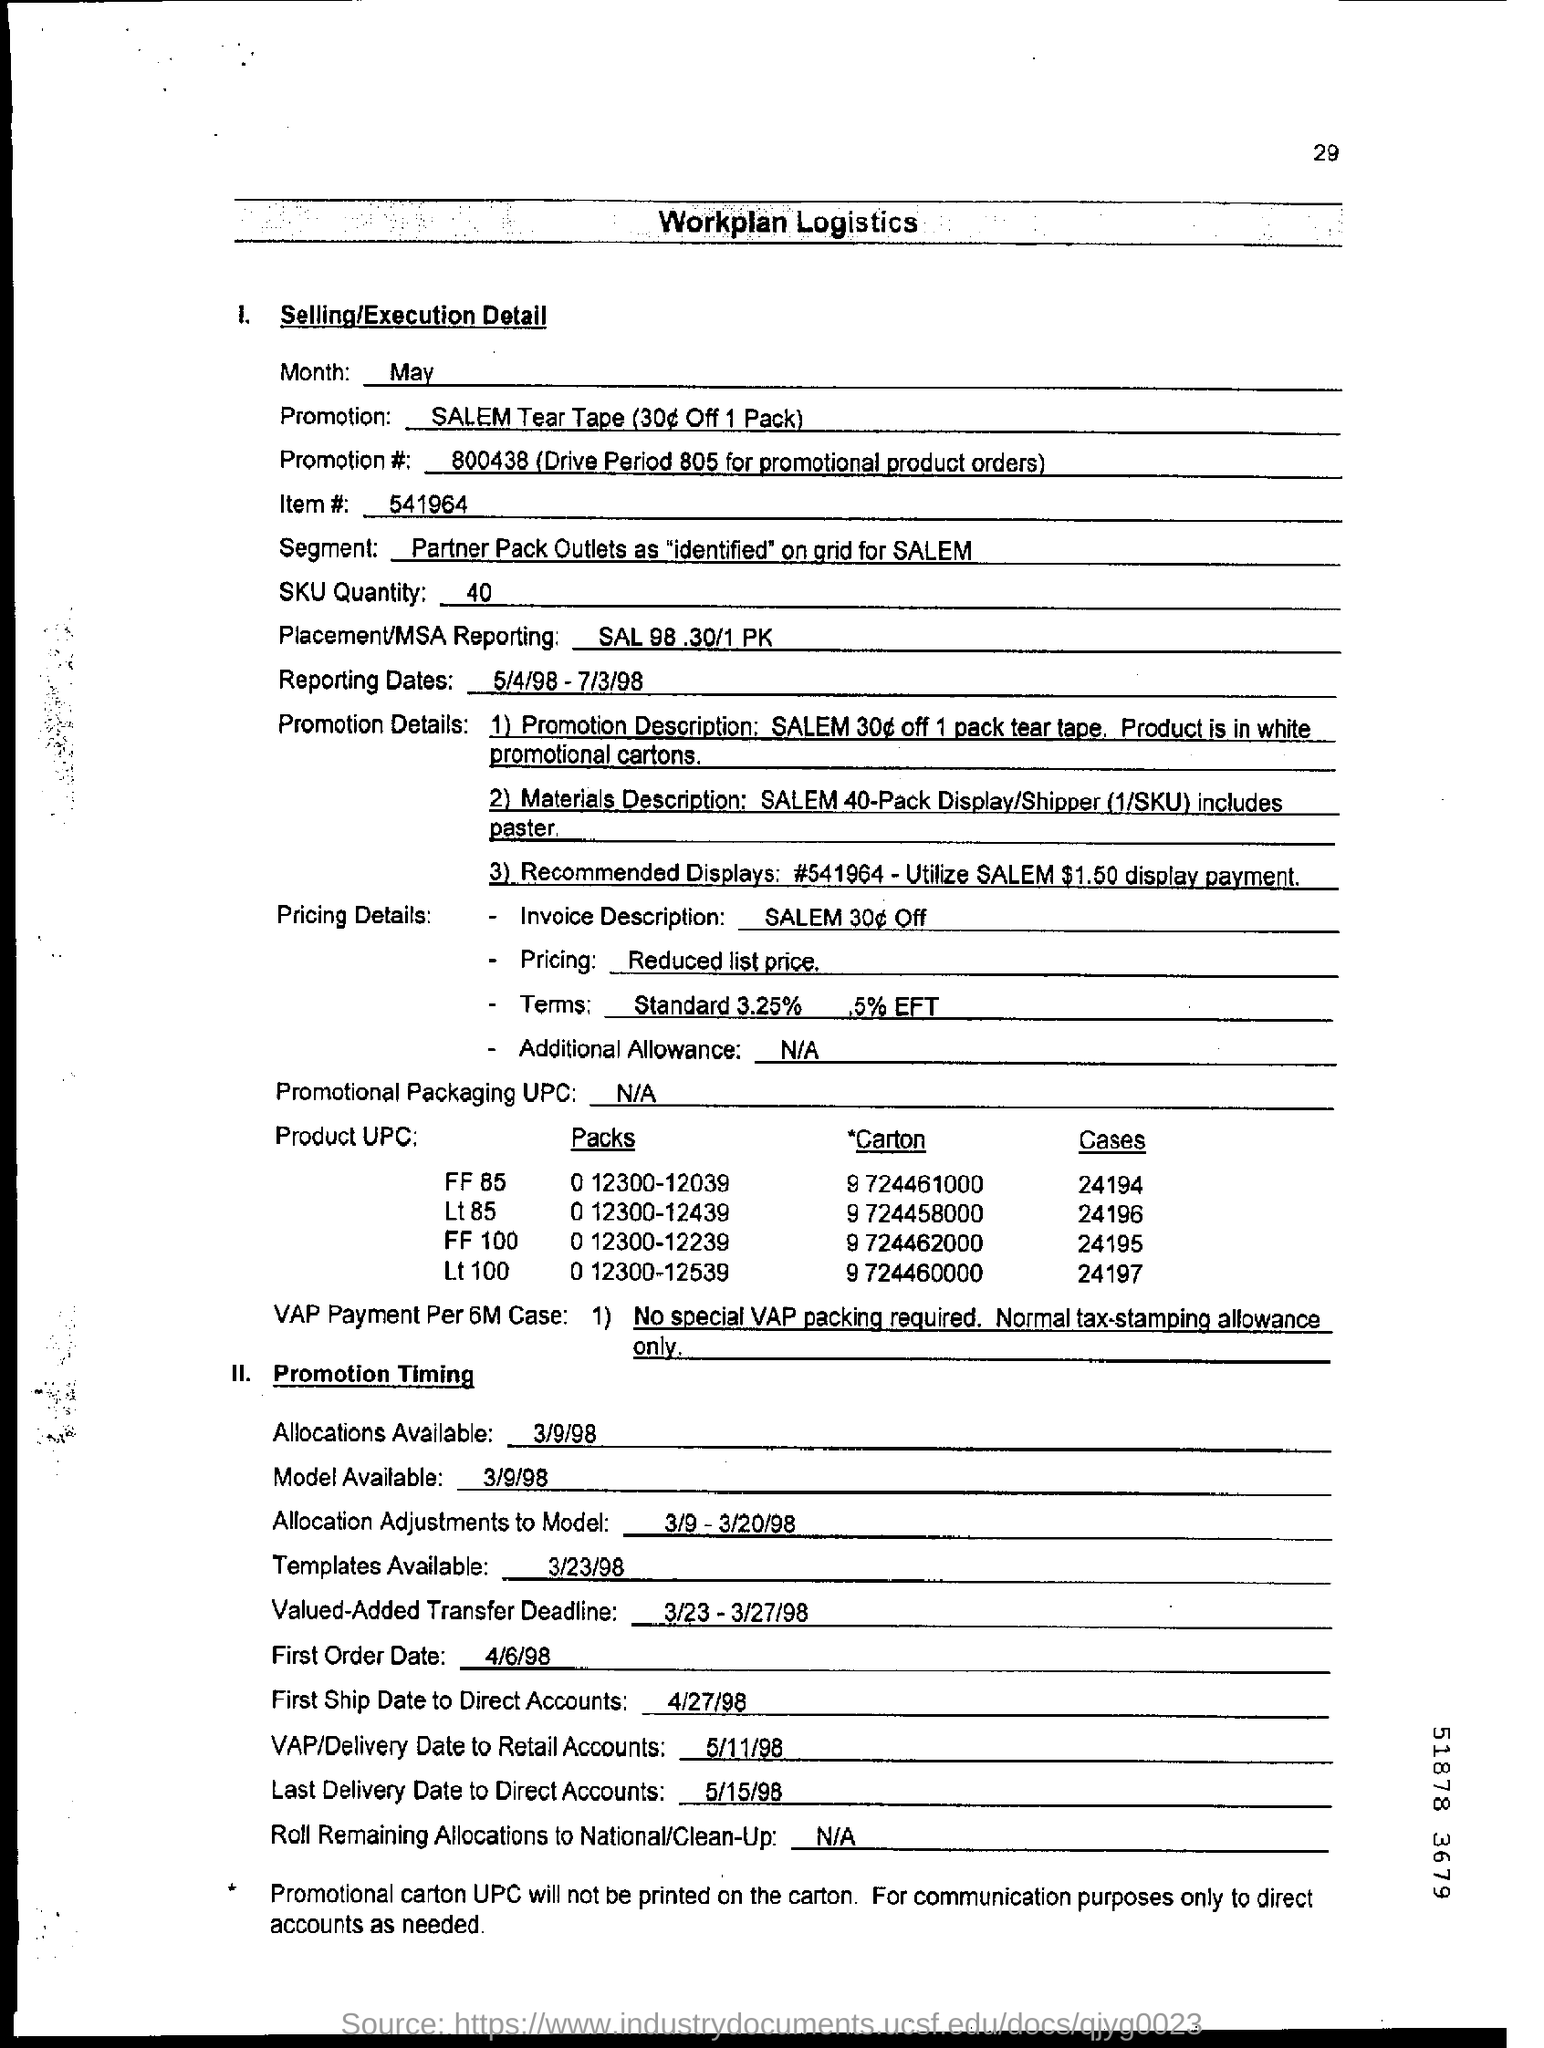What is the last date to deliver direct accounts?
Ensure brevity in your answer.  5/15/98. 